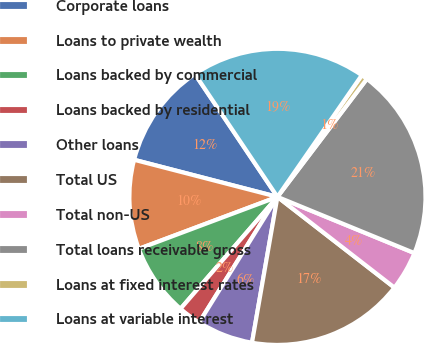<chart> <loc_0><loc_0><loc_500><loc_500><pie_chart><fcel>Corporate loans<fcel>Loans to private wealth<fcel>Loans backed by commercial<fcel>Loans backed by residential<fcel>Other loans<fcel>Total US<fcel>Total non-US<fcel>Total loans receivable gross<fcel>Loans at fixed interest rates<fcel>Loans at variable interest<nl><fcel>11.55%<fcel>9.74%<fcel>7.93%<fcel>2.49%<fcel>6.12%<fcel>17.25%<fcel>4.3%<fcel>20.87%<fcel>0.68%<fcel>19.06%<nl></chart> 